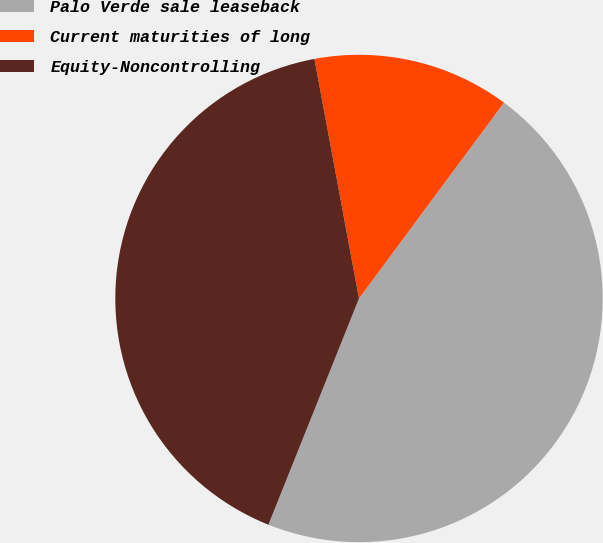<chart> <loc_0><loc_0><loc_500><loc_500><pie_chart><fcel>Palo Verde sale leaseback<fcel>Current maturities of long<fcel>Equity-Noncontrolling<nl><fcel>45.92%<fcel>13.07%<fcel>41.01%<nl></chart> 